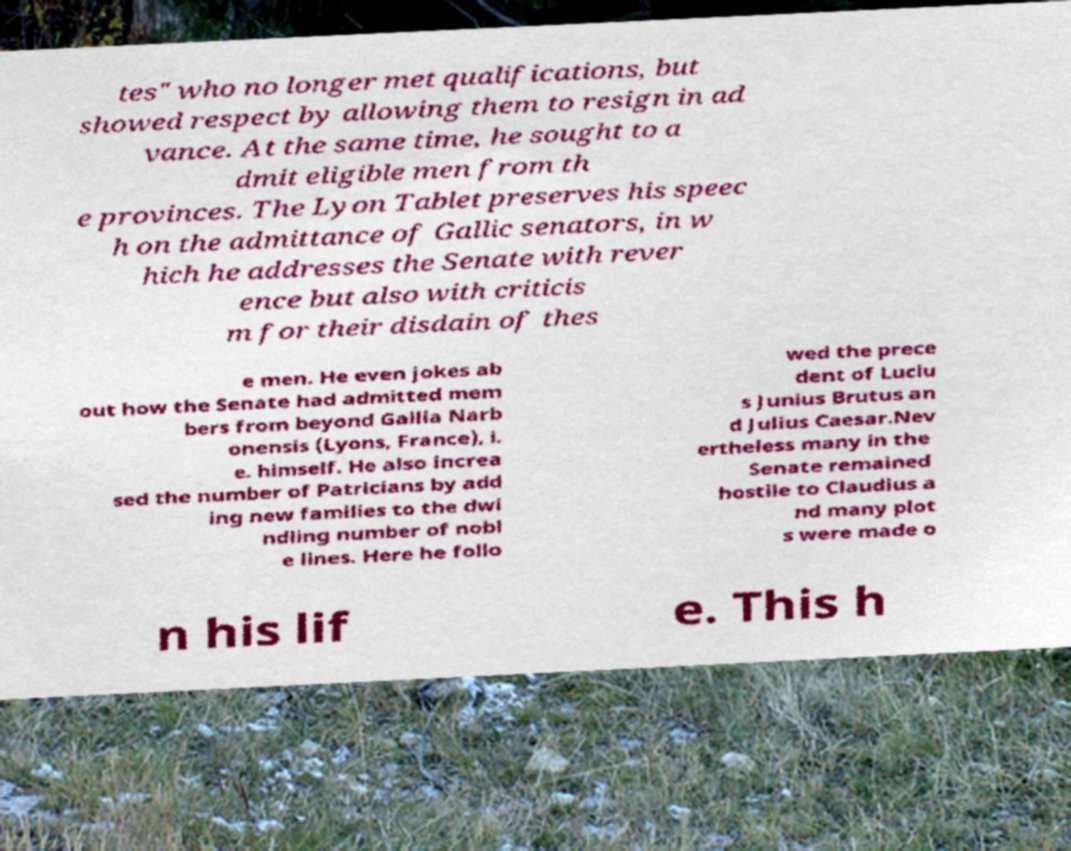Please read and relay the text visible in this image. What does it say? tes" who no longer met qualifications, but showed respect by allowing them to resign in ad vance. At the same time, he sought to a dmit eligible men from th e provinces. The Lyon Tablet preserves his speec h on the admittance of Gallic senators, in w hich he addresses the Senate with rever ence but also with criticis m for their disdain of thes e men. He even jokes ab out how the Senate had admitted mem bers from beyond Gallia Narb onensis (Lyons, France), i. e. himself. He also increa sed the number of Patricians by add ing new families to the dwi ndling number of nobl e lines. Here he follo wed the prece dent of Luciu s Junius Brutus an d Julius Caesar.Nev ertheless many in the Senate remained hostile to Claudius a nd many plot s were made o n his lif e. This h 